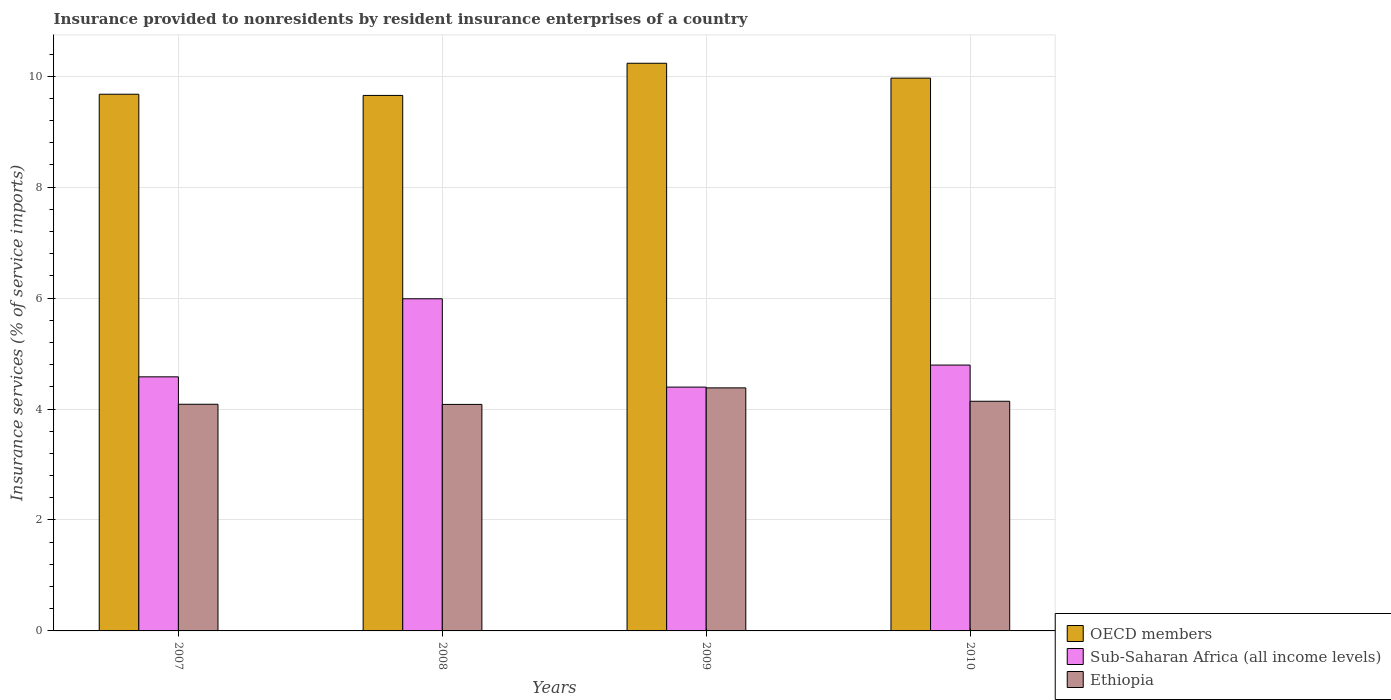Are the number of bars per tick equal to the number of legend labels?
Your answer should be compact. Yes. Are the number of bars on each tick of the X-axis equal?
Your response must be concise. Yes. How many bars are there on the 1st tick from the left?
Offer a very short reply. 3. How many bars are there on the 1st tick from the right?
Offer a terse response. 3. What is the insurance provided to nonresidents in OECD members in 2009?
Provide a short and direct response. 10.23. Across all years, what is the maximum insurance provided to nonresidents in Sub-Saharan Africa (all income levels)?
Provide a short and direct response. 5.99. Across all years, what is the minimum insurance provided to nonresidents in OECD members?
Keep it short and to the point. 9.65. In which year was the insurance provided to nonresidents in Ethiopia maximum?
Provide a succinct answer. 2009. In which year was the insurance provided to nonresidents in OECD members minimum?
Offer a very short reply. 2008. What is the total insurance provided to nonresidents in OECD members in the graph?
Provide a succinct answer. 39.53. What is the difference between the insurance provided to nonresidents in Ethiopia in 2009 and that in 2010?
Provide a succinct answer. 0.24. What is the difference between the insurance provided to nonresidents in OECD members in 2008 and the insurance provided to nonresidents in Ethiopia in 2007?
Provide a short and direct response. 5.57. What is the average insurance provided to nonresidents in OECD members per year?
Give a very brief answer. 9.88. In the year 2010, what is the difference between the insurance provided to nonresidents in Sub-Saharan Africa (all income levels) and insurance provided to nonresidents in OECD members?
Your answer should be very brief. -5.17. What is the ratio of the insurance provided to nonresidents in Ethiopia in 2007 to that in 2008?
Your answer should be very brief. 1. Is the insurance provided to nonresidents in Ethiopia in 2007 less than that in 2008?
Offer a terse response. No. What is the difference between the highest and the second highest insurance provided to nonresidents in Ethiopia?
Your response must be concise. 0.24. What is the difference between the highest and the lowest insurance provided to nonresidents in Ethiopia?
Give a very brief answer. 0.3. What does the 2nd bar from the left in 2007 represents?
Your answer should be very brief. Sub-Saharan Africa (all income levels). What does the 2nd bar from the right in 2010 represents?
Provide a succinct answer. Sub-Saharan Africa (all income levels). Is it the case that in every year, the sum of the insurance provided to nonresidents in Ethiopia and insurance provided to nonresidents in Sub-Saharan Africa (all income levels) is greater than the insurance provided to nonresidents in OECD members?
Make the answer very short. No. How many bars are there?
Offer a terse response. 12. How many years are there in the graph?
Make the answer very short. 4. Does the graph contain any zero values?
Give a very brief answer. No. How many legend labels are there?
Your response must be concise. 3. What is the title of the graph?
Your answer should be very brief. Insurance provided to nonresidents by resident insurance enterprises of a country. What is the label or title of the Y-axis?
Keep it short and to the point. Insurance services (% of service imports). What is the Insurance services (% of service imports) of OECD members in 2007?
Keep it short and to the point. 9.68. What is the Insurance services (% of service imports) in Sub-Saharan Africa (all income levels) in 2007?
Provide a succinct answer. 4.58. What is the Insurance services (% of service imports) of Ethiopia in 2007?
Keep it short and to the point. 4.09. What is the Insurance services (% of service imports) of OECD members in 2008?
Offer a terse response. 9.65. What is the Insurance services (% of service imports) in Sub-Saharan Africa (all income levels) in 2008?
Offer a terse response. 5.99. What is the Insurance services (% of service imports) in Ethiopia in 2008?
Your answer should be very brief. 4.08. What is the Insurance services (% of service imports) of OECD members in 2009?
Your response must be concise. 10.23. What is the Insurance services (% of service imports) in Sub-Saharan Africa (all income levels) in 2009?
Your answer should be very brief. 4.4. What is the Insurance services (% of service imports) in Ethiopia in 2009?
Provide a short and direct response. 4.38. What is the Insurance services (% of service imports) in OECD members in 2010?
Make the answer very short. 9.97. What is the Insurance services (% of service imports) of Sub-Saharan Africa (all income levels) in 2010?
Ensure brevity in your answer.  4.79. What is the Insurance services (% of service imports) in Ethiopia in 2010?
Ensure brevity in your answer.  4.14. Across all years, what is the maximum Insurance services (% of service imports) of OECD members?
Your response must be concise. 10.23. Across all years, what is the maximum Insurance services (% of service imports) in Sub-Saharan Africa (all income levels)?
Your response must be concise. 5.99. Across all years, what is the maximum Insurance services (% of service imports) of Ethiopia?
Provide a short and direct response. 4.38. Across all years, what is the minimum Insurance services (% of service imports) in OECD members?
Ensure brevity in your answer.  9.65. Across all years, what is the minimum Insurance services (% of service imports) of Sub-Saharan Africa (all income levels)?
Offer a very short reply. 4.4. Across all years, what is the minimum Insurance services (% of service imports) of Ethiopia?
Provide a succinct answer. 4.08. What is the total Insurance services (% of service imports) in OECD members in the graph?
Make the answer very short. 39.53. What is the total Insurance services (% of service imports) in Sub-Saharan Africa (all income levels) in the graph?
Provide a short and direct response. 19.76. What is the total Insurance services (% of service imports) in Ethiopia in the graph?
Make the answer very short. 16.69. What is the difference between the Insurance services (% of service imports) in OECD members in 2007 and that in 2008?
Give a very brief answer. 0.02. What is the difference between the Insurance services (% of service imports) of Sub-Saharan Africa (all income levels) in 2007 and that in 2008?
Offer a very short reply. -1.41. What is the difference between the Insurance services (% of service imports) in Ethiopia in 2007 and that in 2008?
Ensure brevity in your answer.  0. What is the difference between the Insurance services (% of service imports) of OECD members in 2007 and that in 2009?
Offer a very short reply. -0.56. What is the difference between the Insurance services (% of service imports) in Sub-Saharan Africa (all income levels) in 2007 and that in 2009?
Your answer should be compact. 0.19. What is the difference between the Insurance services (% of service imports) of Ethiopia in 2007 and that in 2009?
Keep it short and to the point. -0.3. What is the difference between the Insurance services (% of service imports) in OECD members in 2007 and that in 2010?
Make the answer very short. -0.29. What is the difference between the Insurance services (% of service imports) of Sub-Saharan Africa (all income levels) in 2007 and that in 2010?
Make the answer very short. -0.21. What is the difference between the Insurance services (% of service imports) in Ethiopia in 2007 and that in 2010?
Make the answer very short. -0.05. What is the difference between the Insurance services (% of service imports) in OECD members in 2008 and that in 2009?
Offer a very short reply. -0.58. What is the difference between the Insurance services (% of service imports) in Sub-Saharan Africa (all income levels) in 2008 and that in 2009?
Provide a short and direct response. 1.59. What is the difference between the Insurance services (% of service imports) of Ethiopia in 2008 and that in 2009?
Offer a very short reply. -0.3. What is the difference between the Insurance services (% of service imports) in OECD members in 2008 and that in 2010?
Offer a very short reply. -0.31. What is the difference between the Insurance services (% of service imports) of Sub-Saharan Africa (all income levels) in 2008 and that in 2010?
Provide a succinct answer. 1.2. What is the difference between the Insurance services (% of service imports) in Ethiopia in 2008 and that in 2010?
Offer a terse response. -0.06. What is the difference between the Insurance services (% of service imports) of OECD members in 2009 and that in 2010?
Your answer should be compact. 0.27. What is the difference between the Insurance services (% of service imports) in Sub-Saharan Africa (all income levels) in 2009 and that in 2010?
Keep it short and to the point. -0.4. What is the difference between the Insurance services (% of service imports) of Ethiopia in 2009 and that in 2010?
Keep it short and to the point. 0.24. What is the difference between the Insurance services (% of service imports) of OECD members in 2007 and the Insurance services (% of service imports) of Sub-Saharan Africa (all income levels) in 2008?
Make the answer very short. 3.69. What is the difference between the Insurance services (% of service imports) in OECD members in 2007 and the Insurance services (% of service imports) in Ethiopia in 2008?
Offer a terse response. 5.59. What is the difference between the Insurance services (% of service imports) of Sub-Saharan Africa (all income levels) in 2007 and the Insurance services (% of service imports) of Ethiopia in 2008?
Give a very brief answer. 0.5. What is the difference between the Insurance services (% of service imports) of OECD members in 2007 and the Insurance services (% of service imports) of Sub-Saharan Africa (all income levels) in 2009?
Keep it short and to the point. 5.28. What is the difference between the Insurance services (% of service imports) of OECD members in 2007 and the Insurance services (% of service imports) of Ethiopia in 2009?
Offer a very short reply. 5.29. What is the difference between the Insurance services (% of service imports) in Sub-Saharan Africa (all income levels) in 2007 and the Insurance services (% of service imports) in Ethiopia in 2009?
Your answer should be very brief. 0.2. What is the difference between the Insurance services (% of service imports) of OECD members in 2007 and the Insurance services (% of service imports) of Sub-Saharan Africa (all income levels) in 2010?
Your response must be concise. 4.88. What is the difference between the Insurance services (% of service imports) in OECD members in 2007 and the Insurance services (% of service imports) in Ethiopia in 2010?
Give a very brief answer. 5.54. What is the difference between the Insurance services (% of service imports) in Sub-Saharan Africa (all income levels) in 2007 and the Insurance services (% of service imports) in Ethiopia in 2010?
Your answer should be very brief. 0.44. What is the difference between the Insurance services (% of service imports) of OECD members in 2008 and the Insurance services (% of service imports) of Sub-Saharan Africa (all income levels) in 2009?
Provide a succinct answer. 5.26. What is the difference between the Insurance services (% of service imports) in OECD members in 2008 and the Insurance services (% of service imports) in Ethiopia in 2009?
Offer a very short reply. 5.27. What is the difference between the Insurance services (% of service imports) in Sub-Saharan Africa (all income levels) in 2008 and the Insurance services (% of service imports) in Ethiopia in 2009?
Give a very brief answer. 1.61. What is the difference between the Insurance services (% of service imports) in OECD members in 2008 and the Insurance services (% of service imports) in Sub-Saharan Africa (all income levels) in 2010?
Make the answer very short. 4.86. What is the difference between the Insurance services (% of service imports) of OECD members in 2008 and the Insurance services (% of service imports) of Ethiopia in 2010?
Offer a terse response. 5.51. What is the difference between the Insurance services (% of service imports) of Sub-Saharan Africa (all income levels) in 2008 and the Insurance services (% of service imports) of Ethiopia in 2010?
Your answer should be compact. 1.85. What is the difference between the Insurance services (% of service imports) of OECD members in 2009 and the Insurance services (% of service imports) of Sub-Saharan Africa (all income levels) in 2010?
Your answer should be very brief. 5.44. What is the difference between the Insurance services (% of service imports) of OECD members in 2009 and the Insurance services (% of service imports) of Ethiopia in 2010?
Give a very brief answer. 6.09. What is the difference between the Insurance services (% of service imports) in Sub-Saharan Africa (all income levels) in 2009 and the Insurance services (% of service imports) in Ethiopia in 2010?
Offer a terse response. 0.26. What is the average Insurance services (% of service imports) of OECD members per year?
Provide a succinct answer. 9.88. What is the average Insurance services (% of service imports) of Sub-Saharan Africa (all income levels) per year?
Make the answer very short. 4.94. What is the average Insurance services (% of service imports) of Ethiopia per year?
Ensure brevity in your answer.  4.17. In the year 2007, what is the difference between the Insurance services (% of service imports) of OECD members and Insurance services (% of service imports) of Sub-Saharan Africa (all income levels)?
Your answer should be very brief. 5.09. In the year 2007, what is the difference between the Insurance services (% of service imports) in OECD members and Insurance services (% of service imports) in Ethiopia?
Offer a terse response. 5.59. In the year 2007, what is the difference between the Insurance services (% of service imports) in Sub-Saharan Africa (all income levels) and Insurance services (% of service imports) in Ethiopia?
Ensure brevity in your answer.  0.49. In the year 2008, what is the difference between the Insurance services (% of service imports) of OECD members and Insurance services (% of service imports) of Sub-Saharan Africa (all income levels)?
Your answer should be very brief. 3.67. In the year 2008, what is the difference between the Insurance services (% of service imports) in OECD members and Insurance services (% of service imports) in Ethiopia?
Your answer should be compact. 5.57. In the year 2008, what is the difference between the Insurance services (% of service imports) in Sub-Saharan Africa (all income levels) and Insurance services (% of service imports) in Ethiopia?
Ensure brevity in your answer.  1.9. In the year 2009, what is the difference between the Insurance services (% of service imports) in OECD members and Insurance services (% of service imports) in Sub-Saharan Africa (all income levels)?
Provide a short and direct response. 5.84. In the year 2009, what is the difference between the Insurance services (% of service imports) in OECD members and Insurance services (% of service imports) in Ethiopia?
Your response must be concise. 5.85. In the year 2009, what is the difference between the Insurance services (% of service imports) in Sub-Saharan Africa (all income levels) and Insurance services (% of service imports) in Ethiopia?
Keep it short and to the point. 0.01. In the year 2010, what is the difference between the Insurance services (% of service imports) in OECD members and Insurance services (% of service imports) in Sub-Saharan Africa (all income levels)?
Ensure brevity in your answer.  5.17. In the year 2010, what is the difference between the Insurance services (% of service imports) in OECD members and Insurance services (% of service imports) in Ethiopia?
Ensure brevity in your answer.  5.83. In the year 2010, what is the difference between the Insurance services (% of service imports) of Sub-Saharan Africa (all income levels) and Insurance services (% of service imports) of Ethiopia?
Give a very brief answer. 0.65. What is the ratio of the Insurance services (% of service imports) of Sub-Saharan Africa (all income levels) in 2007 to that in 2008?
Your response must be concise. 0.77. What is the ratio of the Insurance services (% of service imports) in OECD members in 2007 to that in 2009?
Your answer should be very brief. 0.95. What is the ratio of the Insurance services (% of service imports) in Sub-Saharan Africa (all income levels) in 2007 to that in 2009?
Provide a short and direct response. 1.04. What is the ratio of the Insurance services (% of service imports) of Ethiopia in 2007 to that in 2009?
Your answer should be very brief. 0.93. What is the ratio of the Insurance services (% of service imports) of OECD members in 2007 to that in 2010?
Offer a very short reply. 0.97. What is the ratio of the Insurance services (% of service imports) of Sub-Saharan Africa (all income levels) in 2007 to that in 2010?
Keep it short and to the point. 0.96. What is the ratio of the Insurance services (% of service imports) of Ethiopia in 2007 to that in 2010?
Keep it short and to the point. 0.99. What is the ratio of the Insurance services (% of service imports) of OECD members in 2008 to that in 2009?
Offer a very short reply. 0.94. What is the ratio of the Insurance services (% of service imports) in Sub-Saharan Africa (all income levels) in 2008 to that in 2009?
Make the answer very short. 1.36. What is the ratio of the Insurance services (% of service imports) in Ethiopia in 2008 to that in 2009?
Your answer should be very brief. 0.93. What is the ratio of the Insurance services (% of service imports) of OECD members in 2008 to that in 2010?
Your answer should be compact. 0.97. What is the ratio of the Insurance services (% of service imports) in Sub-Saharan Africa (all income levels) in 2008 to that in 2010?
Offer a terse response. 1.25. What is the ratio of the Insurance services (% of service imports) of Ethiopia in 2008 to that in 2010?
Offer a terse response. 0.99. What is the ratio of the Insurance services (% of service imports) in OECD members in 2009 to that in 2010?
Keep it short and to the point. 1.03. What is the ratio of the Insurance services (% of service imports) of Sub-Saharan Africa (all income levels) in 2009 to that in 2010?
Offer a terse response. 0.92. What is the ratio of the Insurance services (% of service imports) in Ethiopia in 2009 to that in 2010?
Offer a terse response. 1.06. What is the difference between the highest and the second highest Insurance services (% of service imports) of OECD members?
Make the answer very short. 0.27. What is the difference between the highest and the second highest Insurance services (% of service imports) in Sub-Saharan Africa (all income levels)?
Provide a short and direct response. 1.2. What is the difference between the highest and the second highest Insurance services (% of service imports) of Ethiopia?
Provide a short and direct response. 0.24. What is the difference between the highest and the lowest Insurance services (% of service imports) in OECD members?
Provide a short and direct response. 0.58. What is the difference between the highest and the lowest Insurance services (% of service imports) of Sub-Saharan Africa (all income levels)?
Provide a succinct answer. 1.59. What is the difference between the highest and the lowest Insurance services (% of service imports) of Ethiopia?
Your response must be concise. 0.3. 